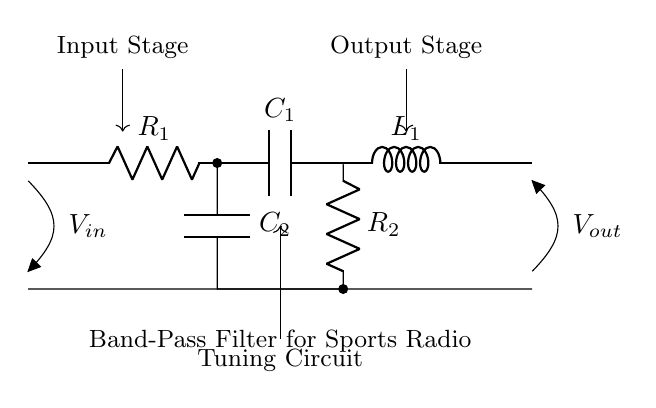What is the type of filter represented in this circuit? The circuit is designed as a band-pass filter, which allows a specific range of frequencies to pass through while attenuating frequencies outside that range. This is evident from the arrangement of resistors, capacitors, and an inductor.
Answer: band-pass filter What is the function of capacitor C1 in this circuit? Capacitor C1 is part of the tuning circuit, which helps define the frequency range that the band-pass filter allows to pass. It interacts with the inductor and resistors to form the resonant circuit.
Answer: tuning Which components are in series in this circuit? The components R1, C1, and L1 are connected in series, forming the main pathway for the input signal through the band-pass filter.
Answer: R1, C1, L1 How many resistors are present in this circuit? There are two resistors in the circuit: R1 and R2, which play roles in shaping the response of the filter.
Answer: two What type of circuit is used for tuning in a band-pass filter? The tuning circuit in this band-pass filter comprises the capacitor C2 and resistor R2, which together allow for adjusting the filter's frequency response.
Answer: tuning circuit What is the relationship between the input and output voltage in this circuit setup? The input voltage is filtered by the band-pass filter, which modifies the output voltage based on the frequency components present in the input signal, allowing only certain frequencies to reach the output.
Answer: filtered response What is the purpose of inductor L1 in this circuit? Inductor L1 is crucial for determining the resonance frequency of the band-pass filter. It works in conjunction with capacitors to create an LC circuit, which is essential for filtering specific frequency ranges.
Answer: resonance frequency 